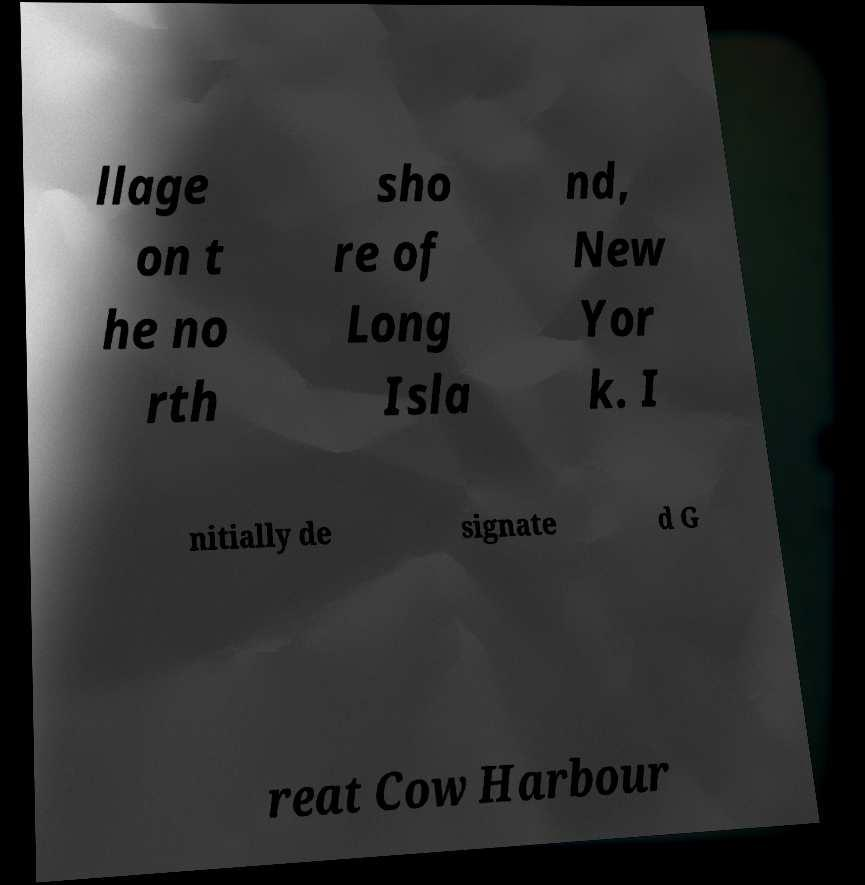Please read and relay the text visible in this image. What does it say? llage on t he no rth sho re of Long Isla nd, New Yor k. I nitially de signate d G reat Cow Harbour 